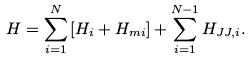Convert formula to latex. <formula><loc_0><loc_0><loc_500><loc_500>H = \sum _ { i = 1 } ^ { N } \left [ H _ { i } + H _ { m i } \right ] + \sum _ { i = 1 } ^ { N - 1 } H _ { J J , i } .</formula> 